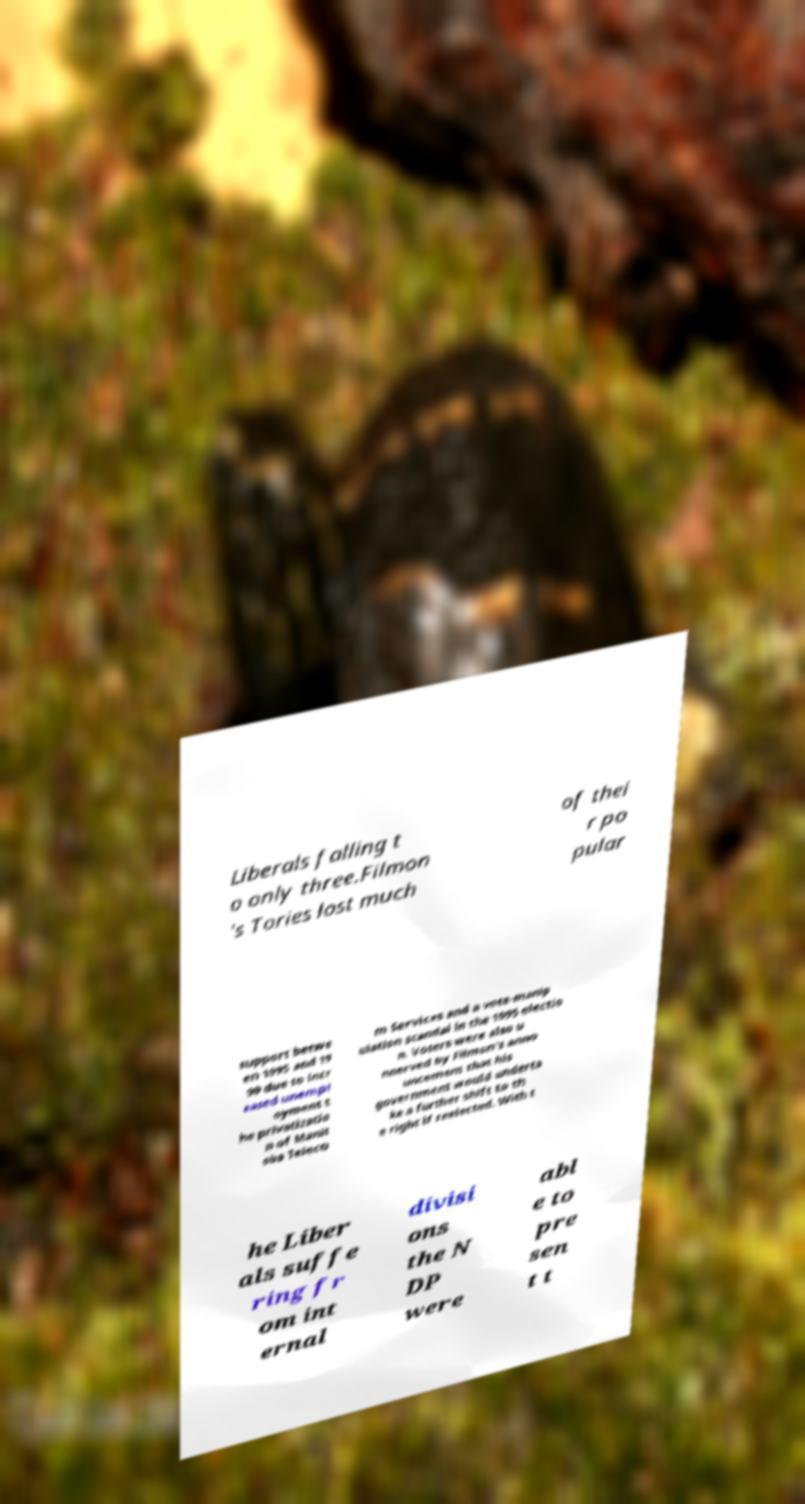There's text embedded in this image that I need extracted. Can you transcribe it verbatim? Liberals falling t o only three.Filmon 's Tories lost much of thei r po pular support betwe en 1995 and 19 99 due to incr eased unempl oyment t he privatizatio n of Manit oba Teleco m Services and a vote-manip ulation scandal in the 1995 electio n. Voters were also u nnerved by Filmon's anno uncement that his government would underta ke a further shift to th e right if reelected. With t he Liber als suffe ring fr om int ernal divisi ons the N DP were abl e to pre sen t t 